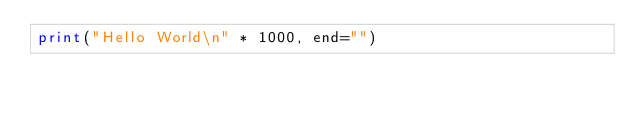<code> <loc_0><loc_0><loc_500><loc_500><_Python_>print("Hello World\n" * 1000, end="")</code> 